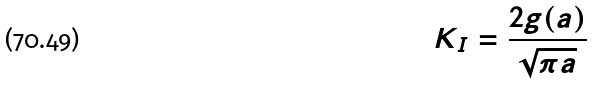Convert formula to latex. <formula><loc_0><loc_0><loc_500><loc_500>K _ { I } = \frac { 2 g ( a ) } { \sqrt { \pi a } }</formula> 